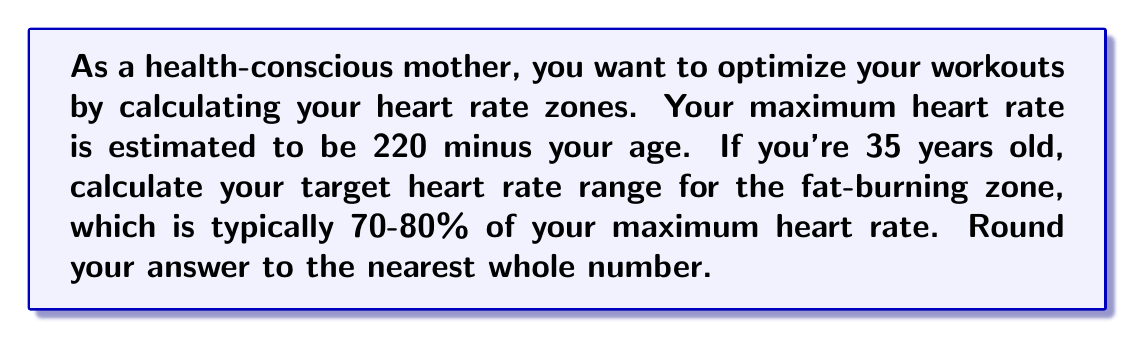Give your solution to this math problem. To solve this problem, we'll follow these steps:

1. Calculate the maximum heart rate:
   $$ \text{Max HR} = 220 - \text{Age} $$
   $$ \text{Max HR} = 220 - 35 = 185 \text{ bpm} $$

2. Calculate the lower bound of the fat-burning zone (70% of max HR):
   $$ \text{Lower bound} = 0.70 \times \text{Max HR} $$
   $$ \text{Lower bound} = 0.70 \times 185 = 129.5 \text{ bpm} $$

3. Calculate the upper bound of the fat-burning zone (80% of max HR):
   $$ \text{Upper bound} = 0.80 \times \text{Max HR} $$
   $$ \text{Upper bound} = 0.80 \times 185 = 148 \text{ bpm} $$

4. Round the results to the nearest whole number:
   Lower bound: 130 bpm (rounded up)
   Upper bound: 148 bpm (already a whole number)

Therefore, the target heart rate range for the fat-burning zone is 130-148 bpm.
Answer: 130-148 bpm 